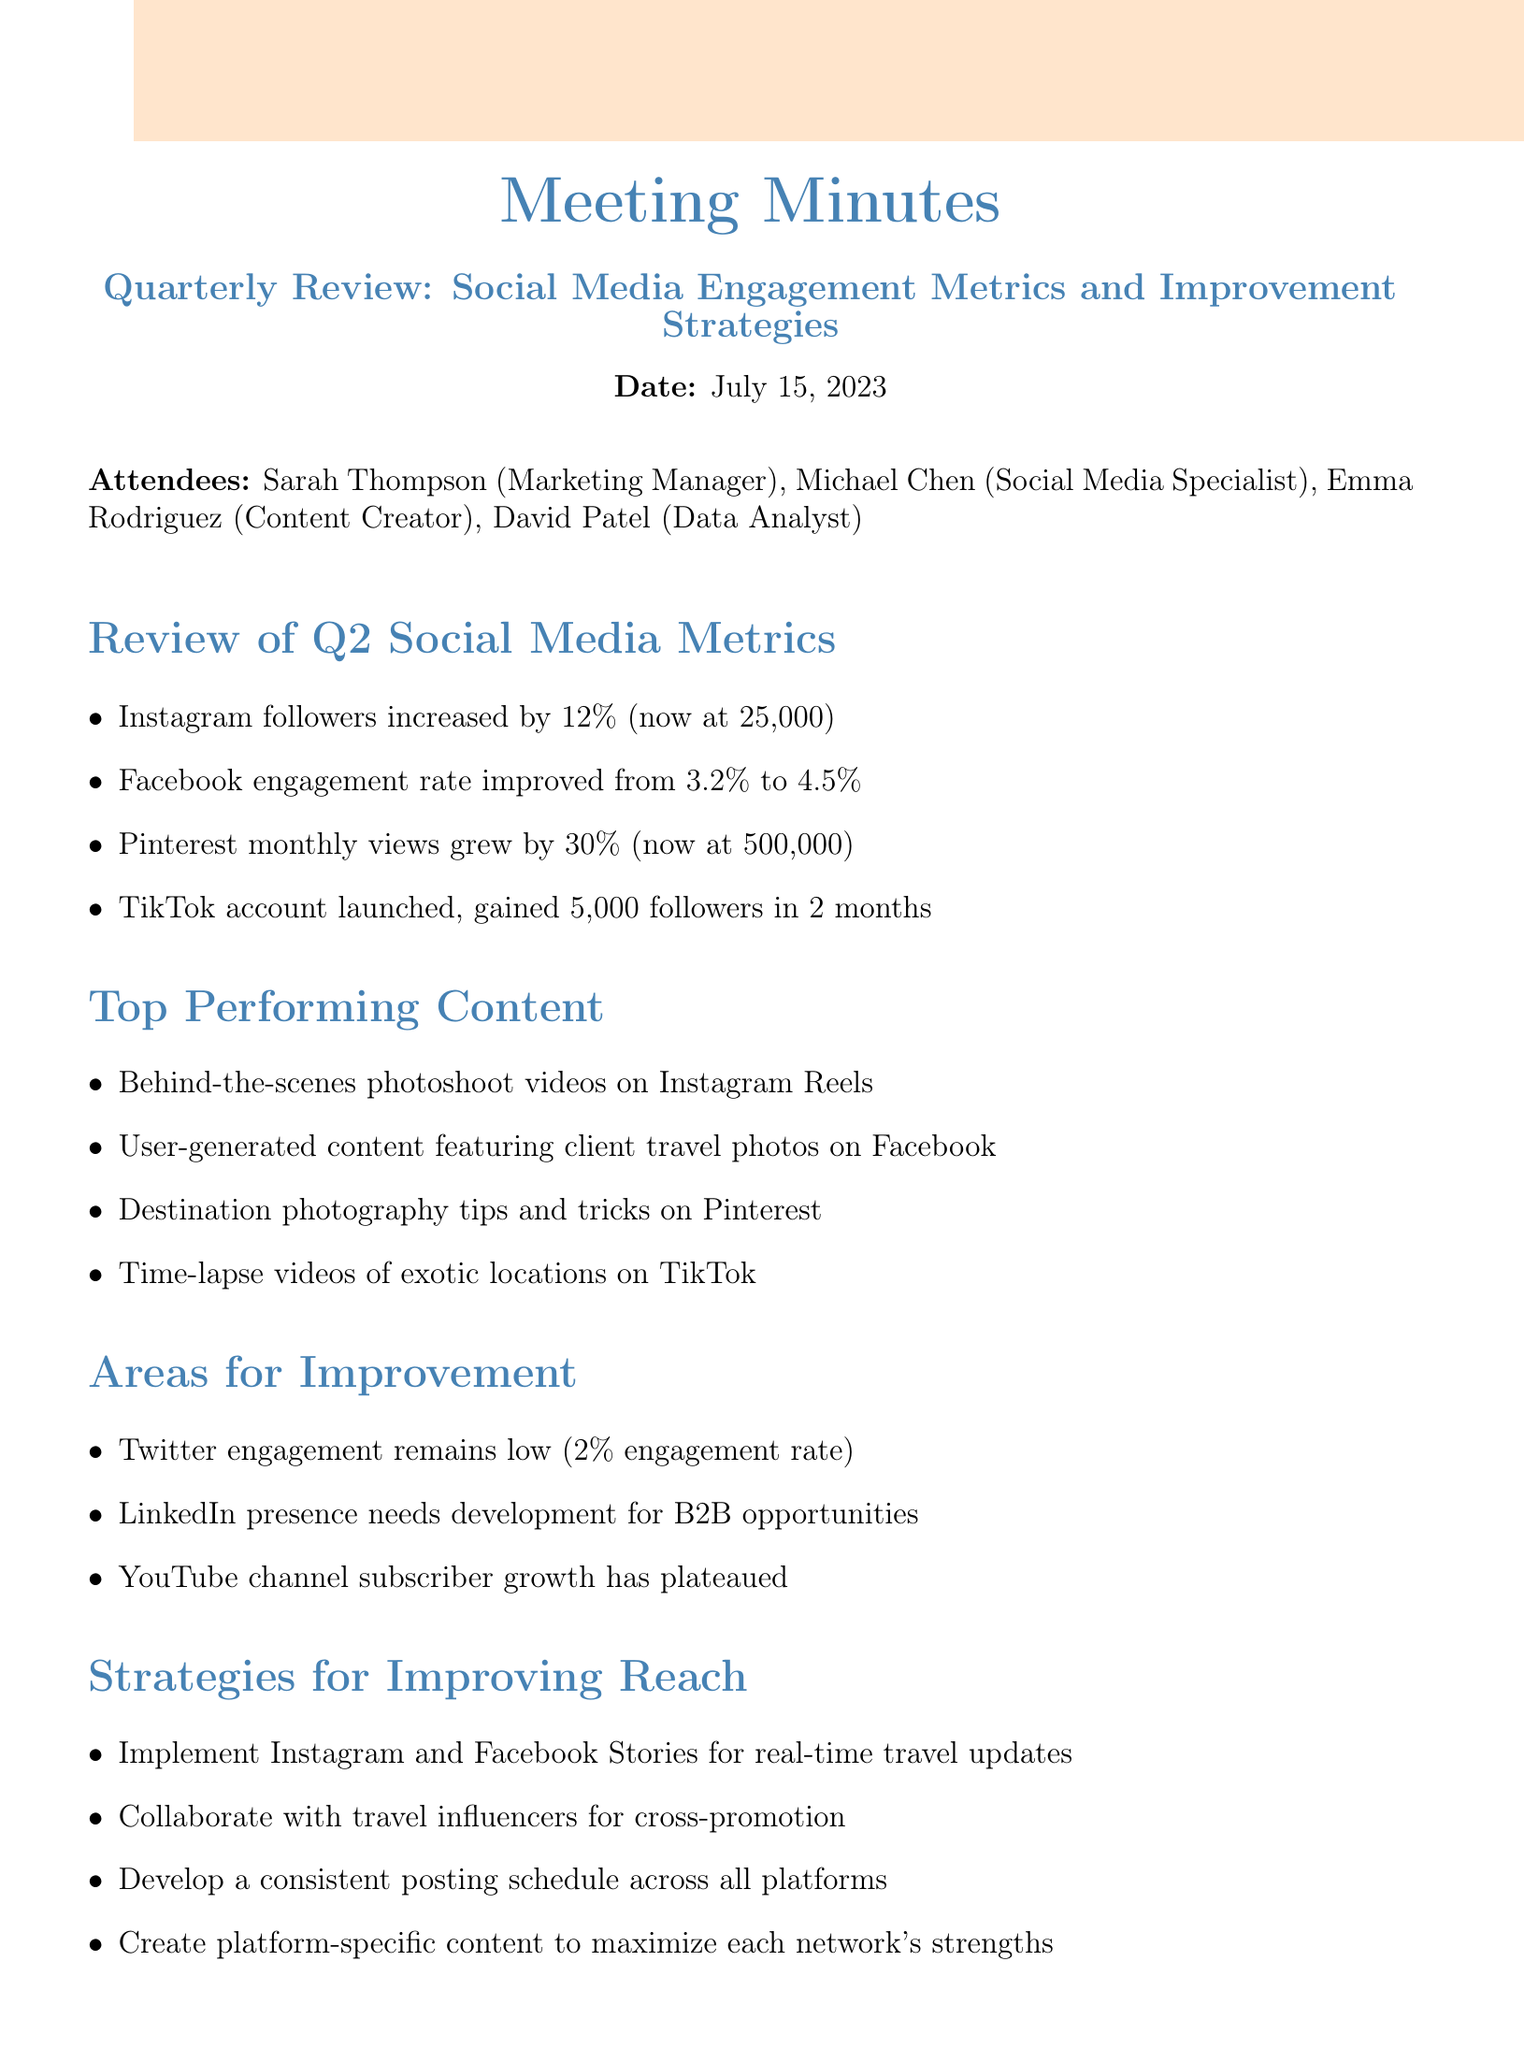What is the date of the meeting? The date of the meeting is listed at the beginning of the document.
Answer: July 15, 2023 How many Instagram followers are there now? The current number of Instagram followers is mentioned in the metrics section of the document.
Answer: 25,000 What was the Facebook engagement rate improvement? The improvement in the Facebook engagement rate is noted in the metrics section.
Answer: from 3.2% to 4.5% What content type performed well on TikTok? The top performing content for TikTok is specified in the content section.
Answer: Time-lapse videos of exotic locations Which platform needs development for B2B opportunities? This information is provided in the areas for improvement section.
Answer: LinkedIn Who is responsible for creating the Q3 content calendar? The action items list includes specific responsibilities assigned to team members.
Answer: Emma What percentage increase did Pinterest monthly views experience? The increase in Pinterest monthly views is stated in the metrics section of the document.
Answer: 30% What are the proposed strategies for improving reach? The strategies for improving reach are clearly listed in the relevant section.
Answer: Implement Instagram and Facebook Stories for real-time travel updates What is an action item related to influencer partnerships? The action items specify tasks assigned to team members.
Answer: Michael to research potential influencer partnerships 